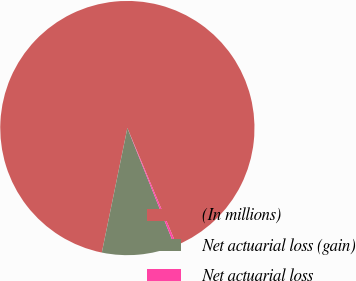Convert chart. <chart><loc_0><loc_0><loc_500><loc_500><pie_chart><fcel>(In millions)<fcel>Net actuarial loss (gain)<fcel>Net actuarial loss<nl><fcel>90.44%<fcel>9.29%<fcel>0.27%<nl></chart> 